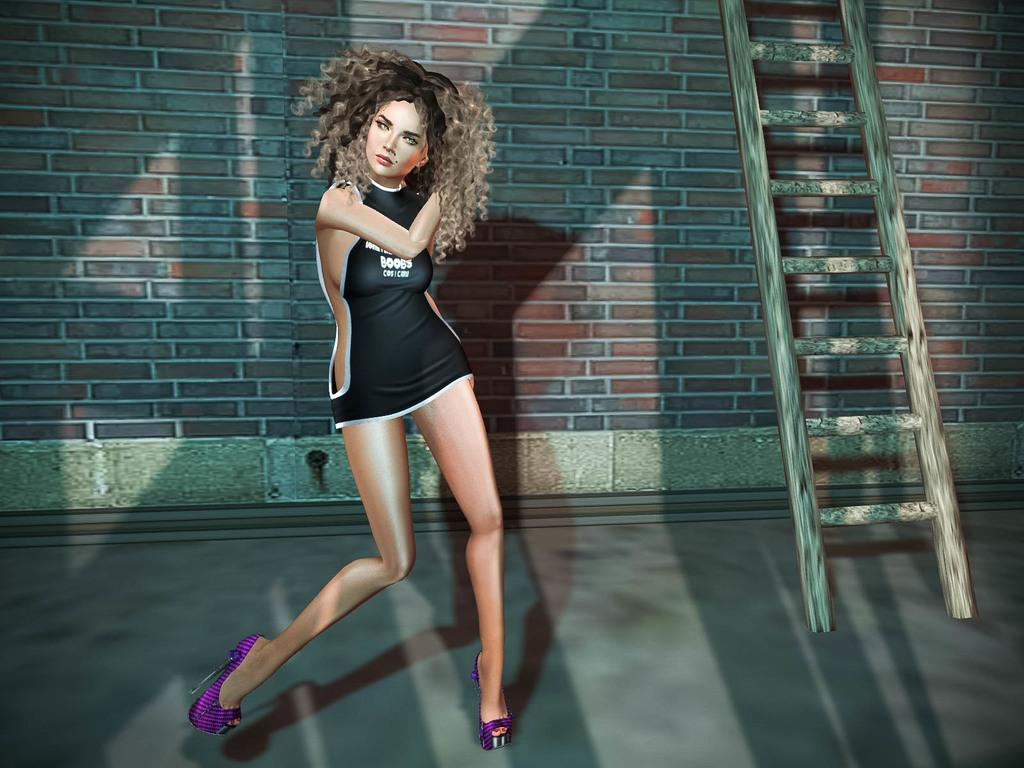<image>
Offer a succinct explanation of the picture presented. A model wears a black mini dress that has the word "boobs" written on the front. 